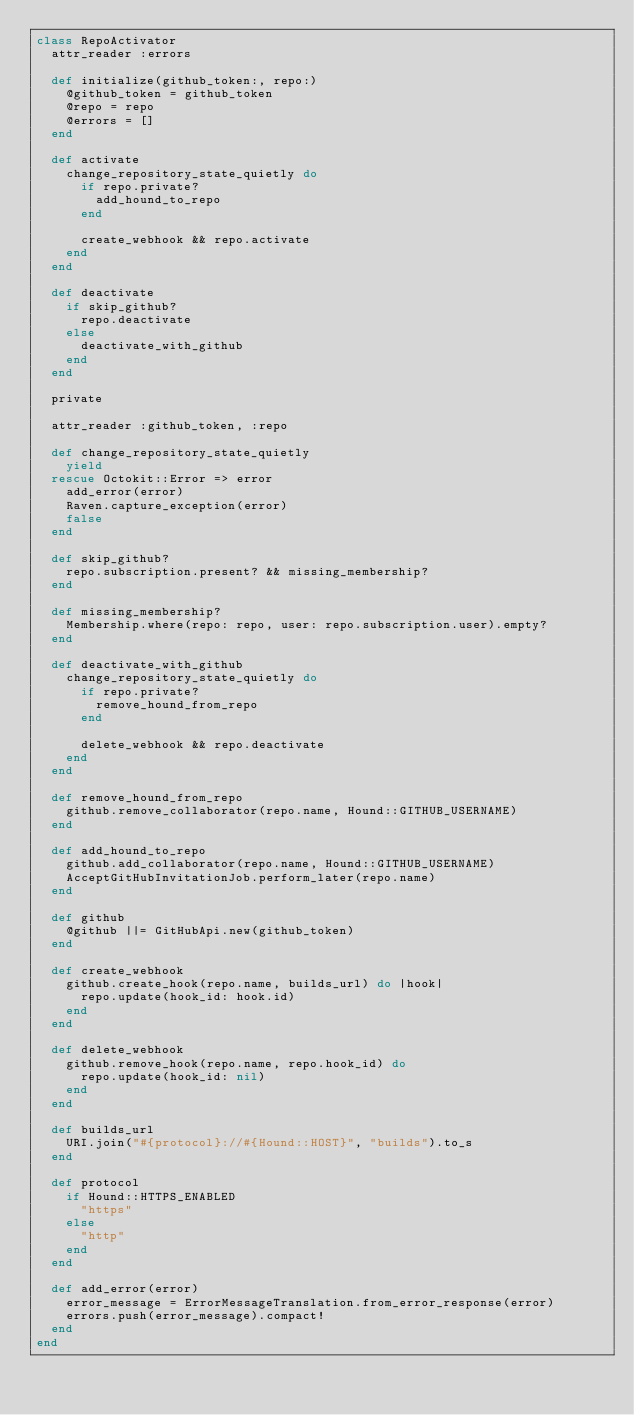Convert code to text. <code><loc_0><loc_0><loc_500><loc_500><_Ruby_>class RepoActivator
  attr_reader :errors

  def initialize(github_token:, repo:)
    @github_token = github_token
    @repo = repo
    @errors = []
  end

  def activate
    change_repository_state_quietly do
      if repo.private?
        add_hound_to_repo
      end

      create_webhook && repo.activate
    end
  end

  def deactivate
    if skip_github?
      repo.deactivate
    else
      deactivate_with_github
    end
  end

  private

  attr_reader :github_token, :repo

  def change_repository_state_quietly
    yield
  rescue Octokit::Error => error
    add_error(error)
    Raven.capture_exception(error)
    false
  end

  def skip_github?
    repo.subscription.present? && missing_membership?
  end

  def missing_membership?
    Membership.where(repo: repo, user: repo.subscription.user).empty?
  end

  def deactivate_with_github
    change_repository_state_quietly do
      if repo.private?
        remove_hound_from_repo
      end

      delete_webhook && repo.deactivate
    end
  end

  def remove_hound_from_repo
    github.remove_collaborator(repo.name, Hound::GITHUB_USERNAME)
  end

  def add_hound_to_repo
    github.add_collaborator(repo.name, Hound::GITHUB_USERNAME)
    AcceptGitHubInvitationJob.perform_later(repo.name)
  end

  def github
    @github ||= GitHubApi.new(github_token)
  end

  def create_webhook
    github.create_hook(repo.name, builds_url) do |hook|
      repo.update(hook_id: hook.id)
    end
  end

  def delete_webhook
    github.remove_hook(repo.name, repo.hook_id) do
      repo.update(hook_id: nil)
    end
  end

  def builds_url
    URI.join("#{protocol}://#{Hound::HOST}", "builds").to_s
  end

  def protocol
    if Hound::HTTPS_ENABLED
      "https"
    else
      "http"
    end
  end

  def add_error(error)
    error_message = ErrorMessageTranslation.from_error_response(error)
    errors.push(error_message).compact!
  end
end
</code> 